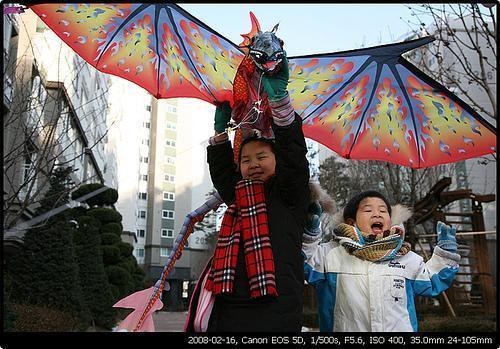How many people are in this picture?
Give a very brief answer. 2. How many children are wearing white coats?
Give a very brief answer. 1. 